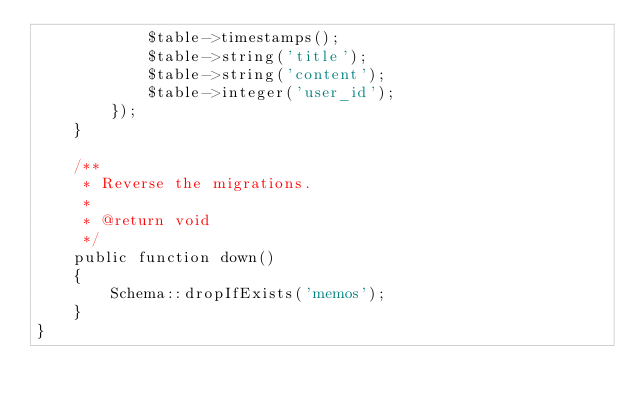<code> <loc_0><loc_0><loc_500><loc_500><_PHP_>            $table->timestamps();
            $table->string('title');
            $table->string('content');
            $table->integer('user_id');
        });
    }

    /**
     * Reverse the migrations.
     *
     * @return void
     */
    public function down()
    {
        Schema::dropIfExists('memos');
    }
}
</code> 